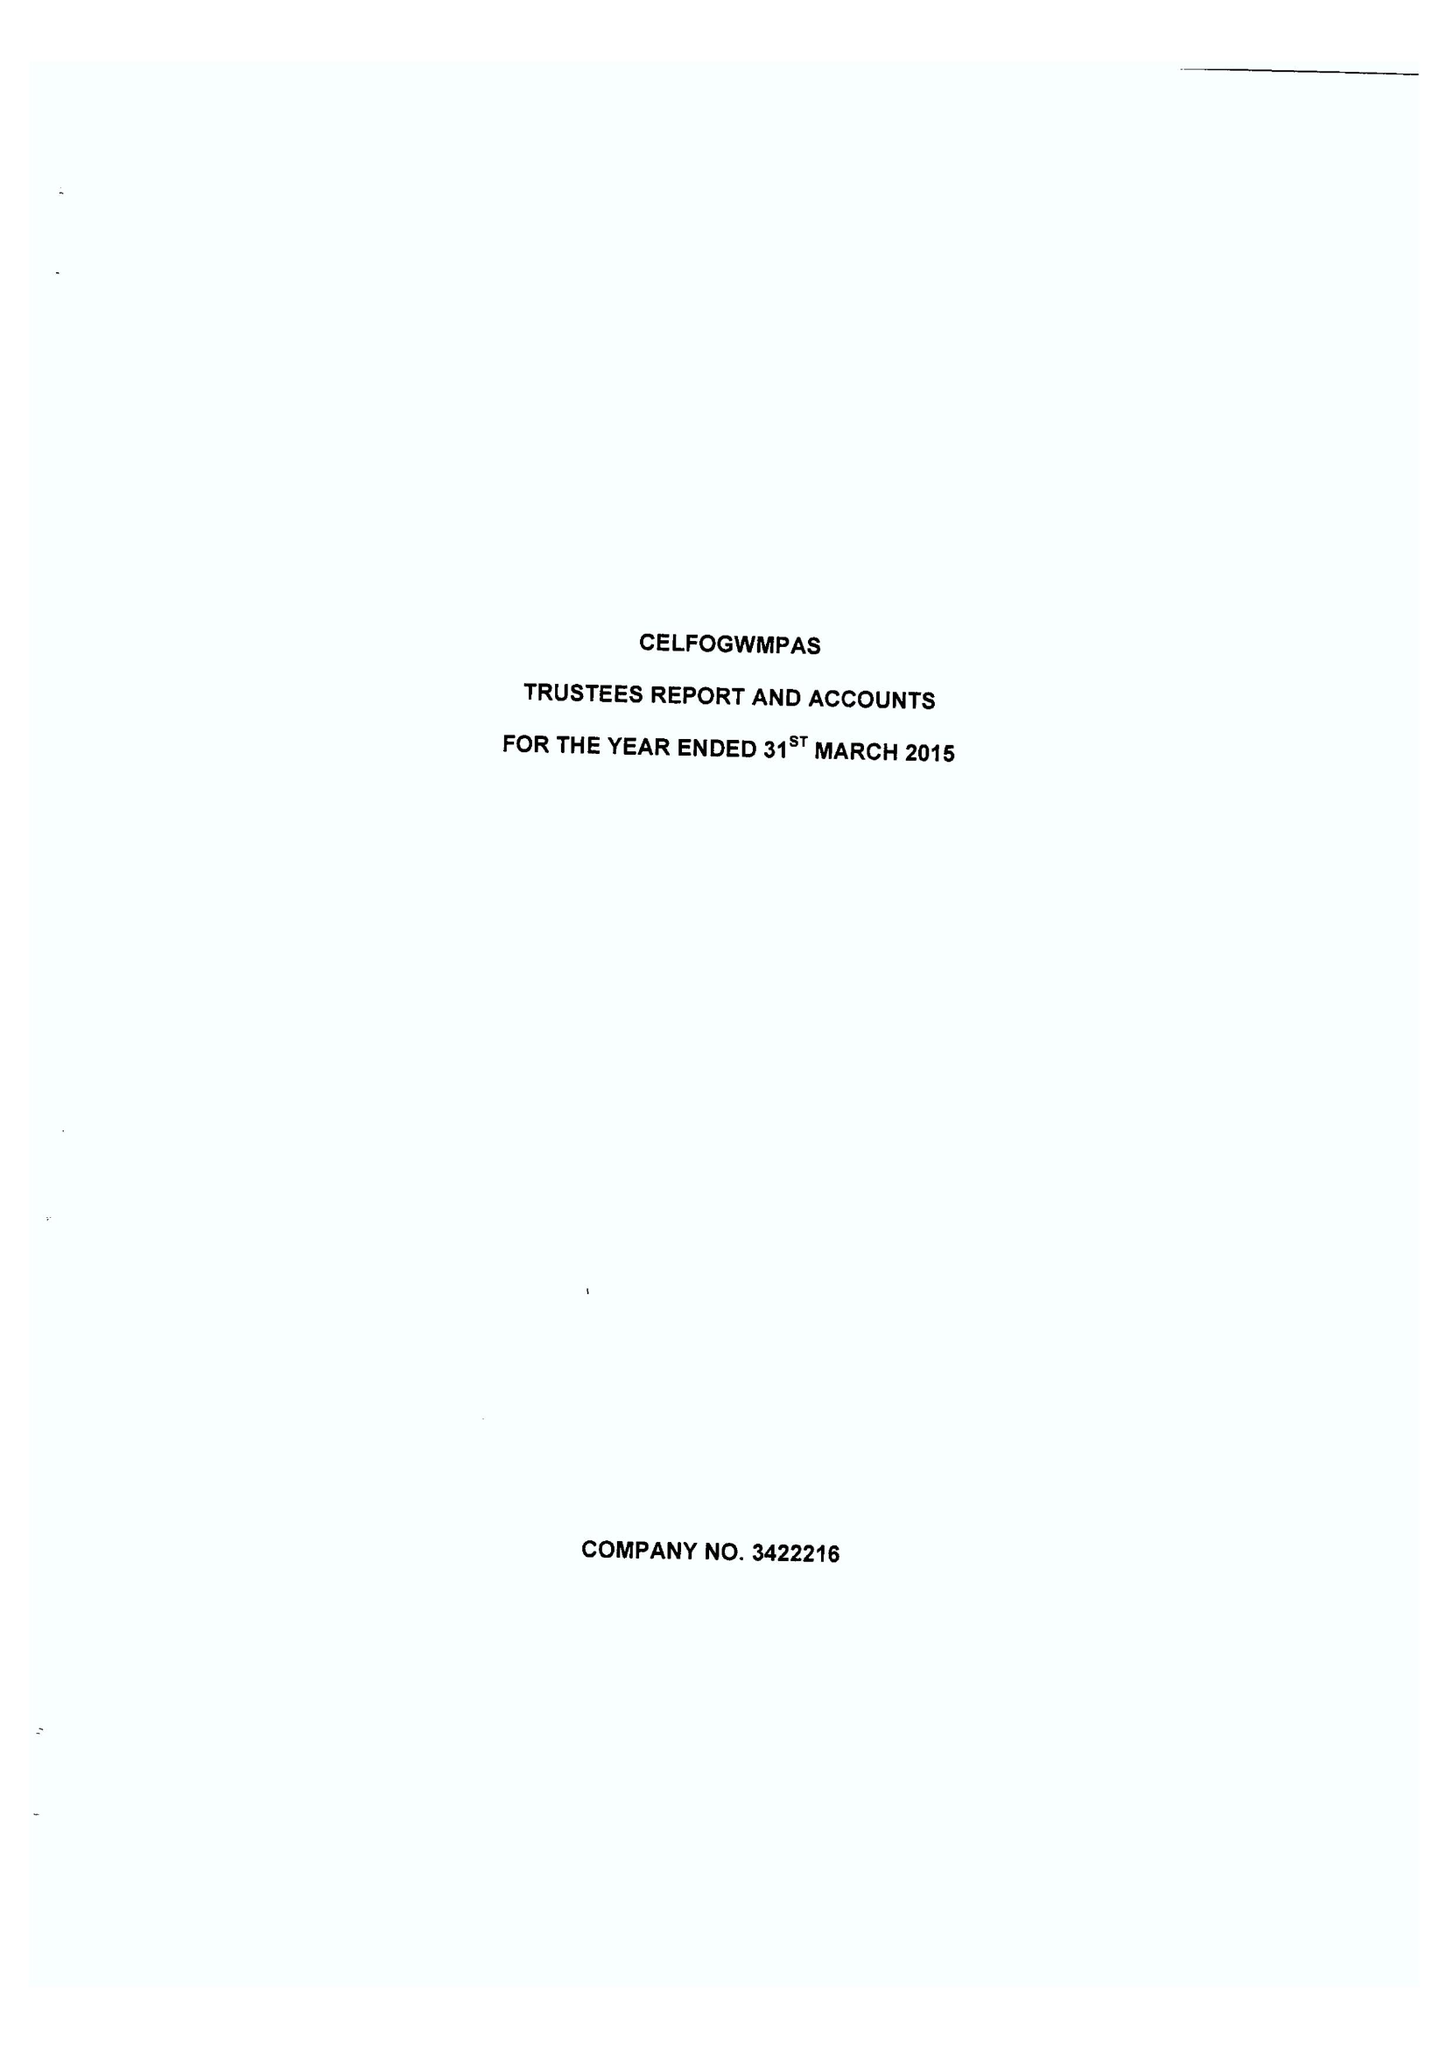What is the value for the charity_name?
Answer the question using a single word or phrase. Celfogwmpas 